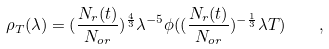<formula> <loc_0><loc_0><loc_500><loc_500>\rho _ { T } ( \lambda ) = ( \frac { N _ { r } ( t ) } { N _ { o r } } ) ^ { \frac { 4 } { 3 } } \lambda ^ { - 5 } \phi ( ( \frac { N _ { r } ( t ) } { N _ { o r } } ) ^ { - \frac { 1 } { 3 } } \lambda T ) \quad ,</formula> 